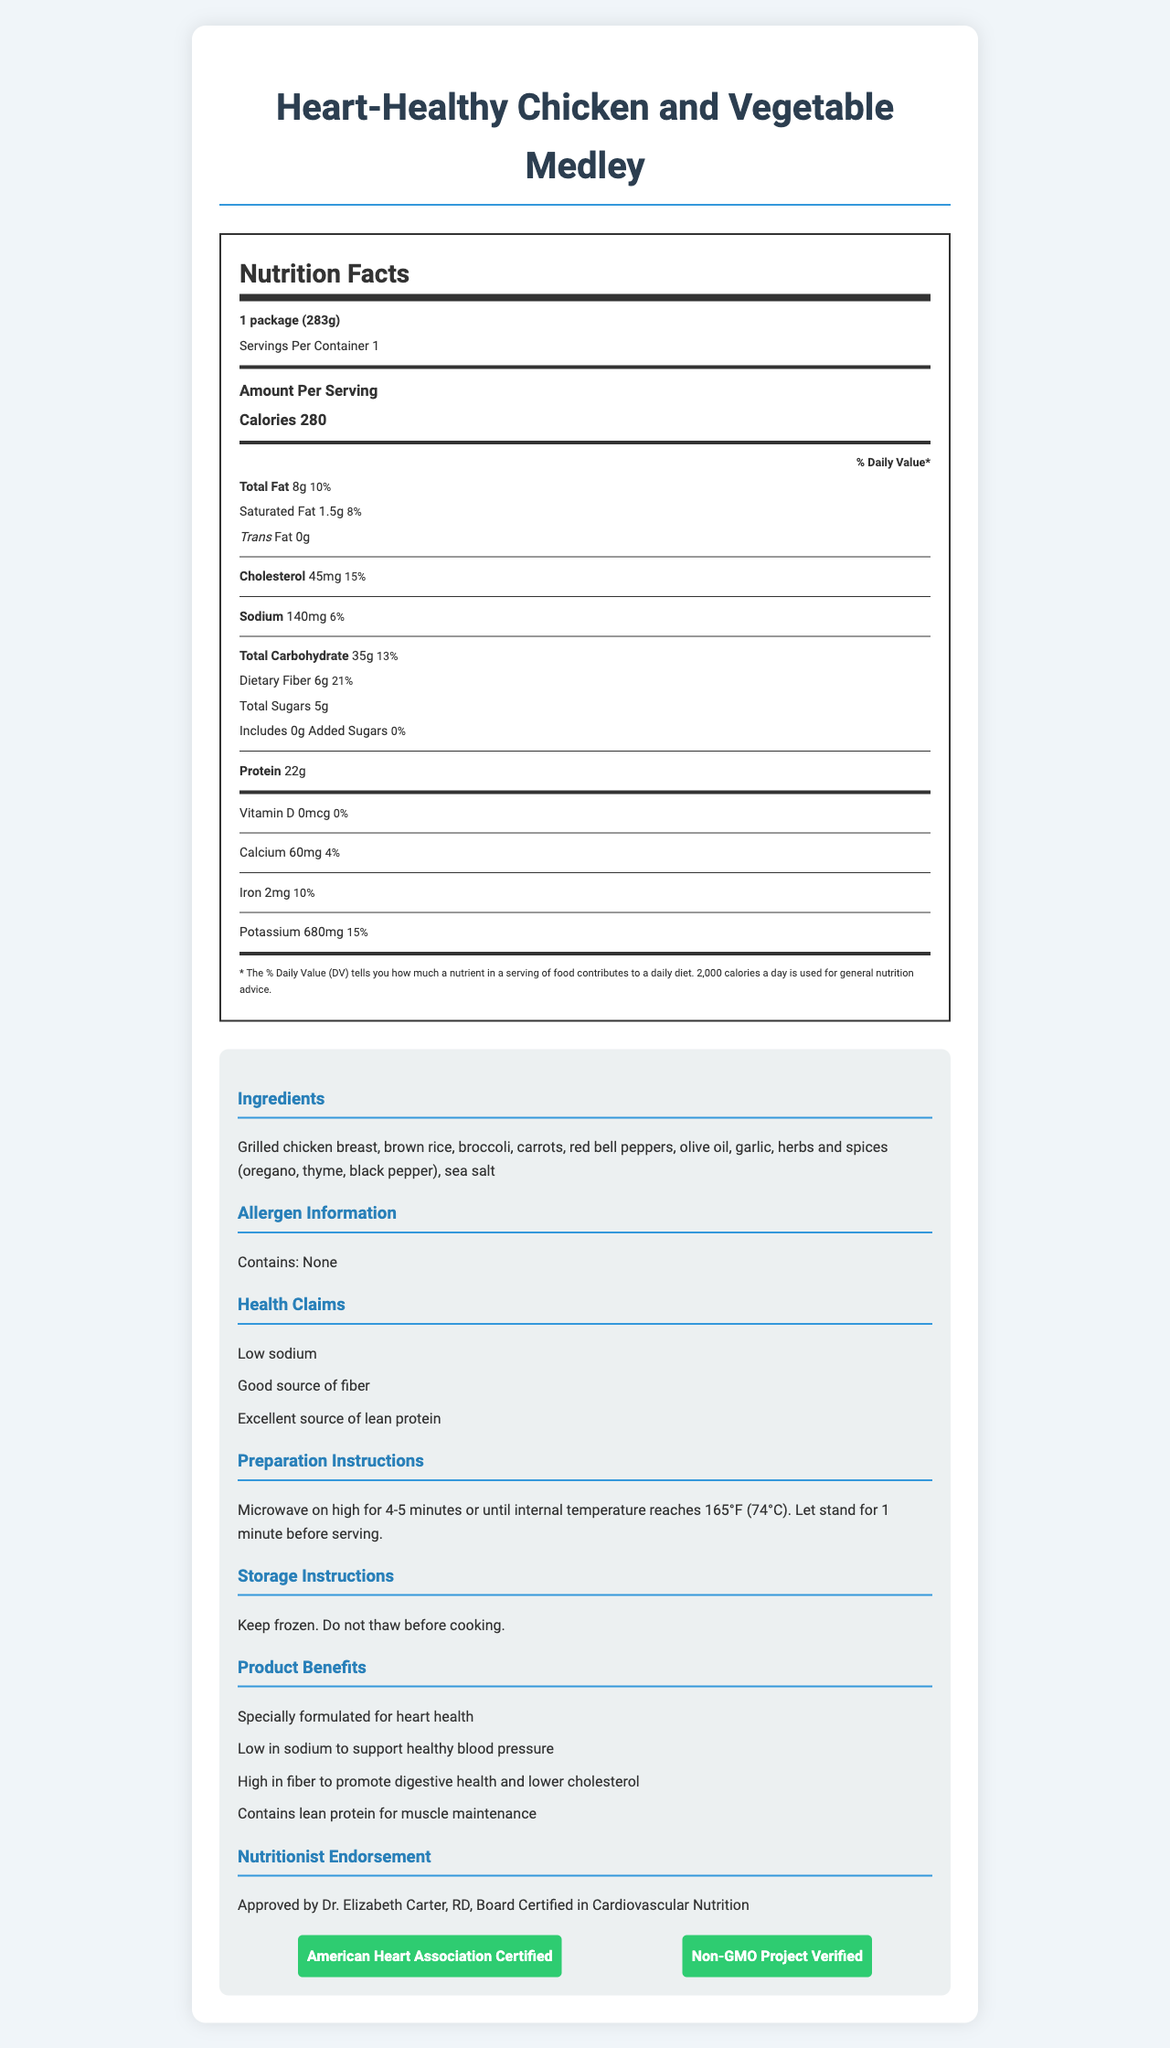what is the serving size of the Heart-Healthy Chicken and Vegetable Medley? The serving size is listed in the Nutrition Facts section at the top of the label as "1 package (283g)."
Answer: 1 package (283g) how many calories are in one serving? The number of calories per serving is displayed prominently in the document under the "Amount Per Serving" section.
Answer: 280 what is the total fat content per serving and its Daily Value percentage? The total fat content is "8g" and the Daily Value percentage is "10%," as stated in the nutritional information.
Answer: 8g, 10% what is the dietary fiber content, and what percentage of the Daily Value does it represent? The dietary fiber content is "6g," and it represents "21%" of the Daily Value.
Answer: 6g, 21% how much sodium does the meal contain? The sodium content is listed as "140mg" in the nutritional information section.
Answer: 140mg which of the following nutrients is not present in significant amounts in this product?
A. Vitamin D
B. Protein
C. Iron
D. Potassium Vitamin D has "0mcg" and "0%" Daily Value, indicating it is not present in significant amounts.
Answer: A. Vitamin D what are the main ingredients in this frozen meal? The main ingredients are listed in the "Ingredients" section of the product information.
Answer: Grilled chicken breast, brown rice, broccoli, carrots, red bell peppers, olive oil, garlic, herbs and spices (oregano, thyme, black pepper), sea salt is this product recommended for heart health? The product is specifically formulated for heart health, as indicated by multiple health claims and its certification from the American Heart Association.
Answer: Yes what is the certification status of this product? The certification status is displayed in the document's certifications section.
Answer: American Heart Association Certified, Non-GMO Project Verified summarize the main benefits of this Heart-Healthy Chicken and Vegetable Medley. The summary captures the key product benefits, health claims, target audience, and endorsements.
Answer: The Heart-Healthy Chicken and Vegetable Medley is specially formulated for heart health, is low in sodium to support healthy blood pressure, high in fiber to promote digestive health and lower cholesterol, and contains lean protein for muscle maintenance. It is certified by the American Heart Association and is Non-GMO Project Verified. what amount of added sugars does the meal include? The document lists "Includes 0g Added Sugars," indicating no added sugars are present in the meal.
Answer: 0g how should this frozen meal be prepared? The preparation instructions indicate microwaving the meal on high for 4-5 minutes or until it reaches an internal temperature of 165°F, followed by a 1-minute standing time.
Answer: Microwave on high for 4-5 minutes or until internal temperature reaches 165°F (74°C). Let stand for 1 minute before serving. can this meal be stored at room temperature before cooking? The storage instructions specify "Keep frozen. Do not thaw before cooking."
Answer: No who endorses the nutritional value of this product? The document mentions the endorsement by Dr. Elizabeth Carter, RD, who is board certified in cardiovascular nutrition.
Answer: Dr. Elizabeth Carter, RD, Board Certified in Cardiovascular Nutrition how much protein does one serving provide? The protein content per serving is listed as "22g."
Answer: 22g are any common allergens present in the meal? The allergen information states "Contains: None," indicating no common allergens are present.
Answer: No what is the primary target audience for this product? The document identifies the target audience as adults aged 50+ who are concerned about heart health.
Answer: Adults aged 50+ concerned about heart health what is the total carbohydrate content and its Daily Value percentage? The total carbohydrate content is "35g," and it represents "13%" of the Daily Value.
Answer: 35g, 13% what type of packaging is used for the product? A. BPA-free, microwave-safe tray B. Plastic container C. Glass jar The packaging type mentioned is a "BPA-free, microwave-safe tray with recyclable cardboard sleeve."
Answer: A. BPA-free, microwave-safe tray what are the calories from fat in the meal? The Nutrition Facts Label does not provide an explicit value for calories from fat. Only the total calories and fat content in grams are provided.
Answer: Not enough information 